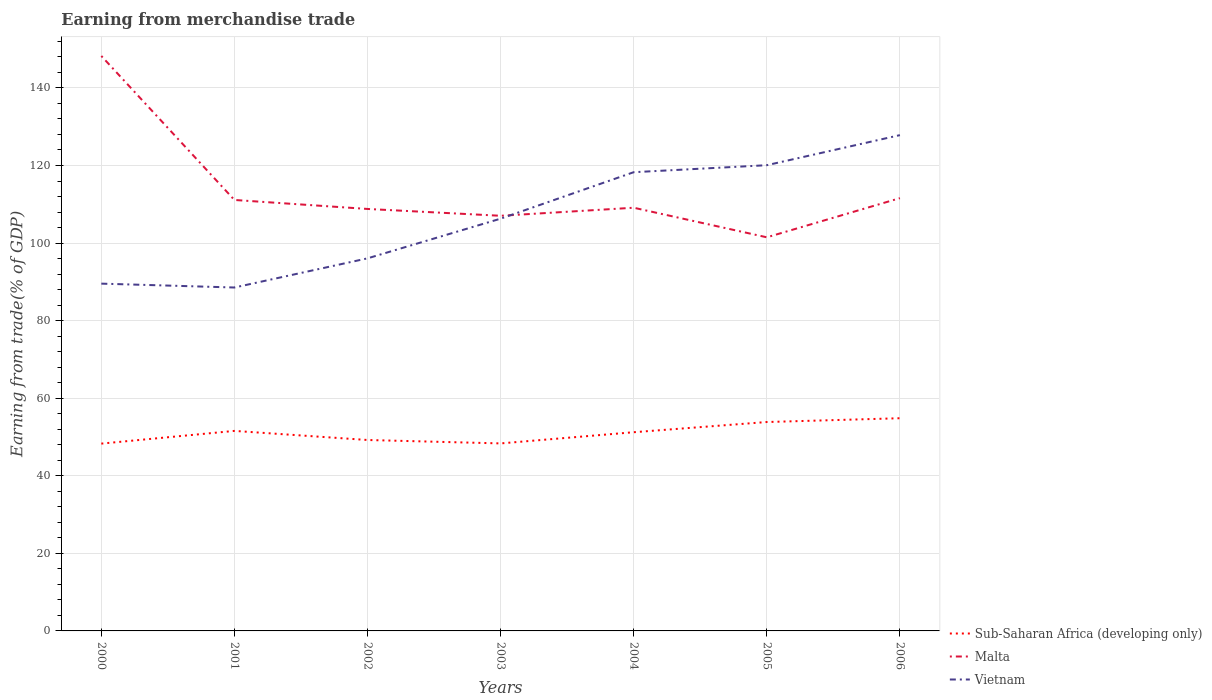How many different coloured lines are there?
Offer a terse response. 3. Is the number of lines equal to the number of legend labels?
Ensure brevity in your answer.  Yes. Across all years, what is the maximum earnings from trade in Sub-Saharan Africa (developing only)?
Provide a short and direct response. 48.29. What is the total earnings from trade in Malta in the graph?
Your answer should be very brief. 2.32. What is the difference between the highest and the second highest earnings from trade in Sub-Saharan Africa (developing only)?
Your answer should be compact. 6.54. Is the earnings from trade in Vietnam strictly greater than the earnings from trade in Sub-Saharan Africa (developing only) over the years?
Provide a succinct answer. No. How many lines are there?
Your answer should be compact. 3. How many years are there in the graph?
Provide a short and direct response. 7. What is the difference between two consecutive major ticks on the Y-axis?
Provide a succinct answer. 20. Does the graph contain any zero values?
Offer a very short reply. No. Does the graph contain grids?
Give a very brief answer. Yes. What is the title of the graph?
Give a very brief answer. Earning from merchandise trade. Does "Vanuatu" appear as one of the legend labels in the graph?
Your response must be concise. No. What is the label or title of the Y-axis?
Make the answer very short. Earning from trade(% of GDP). What is the Earning from trade(% of GDP) in Sub-Saharan Africa (developing only) in 2000?
Keep it short and to the point. 48.29. What is the Earning from trade(% of GDP) of Malta in 2000?
Your answer should be compact. 148.24. What is the Earning from trade(% of GDP) in Vietnam in 2000?
Your answer should be very brief. 89.54. What is the Earning from trade(% of GDP) in Sub-Saharan Africa (developing only) in 2001?
Offer a terse response. 51.57. What is the Earning from trade(% of GDP) of Malta in 2001?
Make the answer very short. 111.11. What is the Earning from trade(% of GDP) of Vietnam in 2001?
Give a very brief answer. 88.54. What is the Earning from trade(% of GDP) in Sub-Saharan Africa (developing only) in 2002?
Make the answer very short. 49.22. What is the Earning from trade(% of GDP) in Malta in 2002?
Your response must be concise. 108.79. What is the Earning from trade(% of GDP) in Vietnam in 2002?
Ensure brevity in your answer.  96.06. What is the Earning from trade(% of GDP) of Sub-Saharan Africa (developing only) in 2003?
Give a very brief answer. 48.35. What is the Earning from trade(% of GDP) in Malta in 2003?
Provide a succinct answer. 107.03. What is the Earning from trade(% of GDP) of Vietnam in 2003?
Offer a very short reply. 106.29. What is the Earning from trade(% of GDP) of Sub-Saharan Africa (developing only) in 2004?
Provide a short and direct response. 51.23. What is the Earning from trade(% of GDP) in Malta in 2004?
Your answer should be compact. 109.11. What is the Earning from trade(% of GDP) of Vietnam in 2004?
Keep it short and to the point. 118.27. What is the Earning from trade(% of GDP) in Sub-Saharan Africa (developing only) in 2005?
Ensure brevity in your answer.  53.86. What is the Earning from trade(% of GDP) of Malta in 2005?
Give a very brief answer. 101.48. What is the Earning from trade(% of GDP) of Vietnam in 2005?
Provide a succinct answer. 120.07. What is the Earning from trade(% of GDP) in Sub-Saharan Africa (developing only) in 2006?
Make the answer very short. 54.84. What is the Earning from trade(% of GDP) of Malta in 2006?
Provide a succinct answer. 111.58. What is the Earning from trade(% of GDP) of Vietnam in 2006?
Provide a short and direct response. 127.83. Across all years, what is the maximum Earning from trade(% of GDP) in Sub-Saharan Africa (developing only)?
Your response must be concise. 54.84. Across all years, what is the maximum Earning from trade(% of GDP) of Malta?
Give a very brief answer. 148.24. Across all years, what is the maximum Earning from trade(% of GDP) of Vietnam?
Offer a terse response. 127.83. Across all years, what is the minimum Earning from trade(% of GDP) in Sub-Saharan Africa (developing only)?
Keep it short and to the point. 48.29. Across all years, what is the minimum Earning from trade(% of GDP) of Malta?
Give a very brief answer. 101.48. Across all years, what is the minimum Earning from trade(% of GDP) in Vietnam?
Keep it short and to the point. 88.54. What is the total Earning from trade(% of GDP) in Sub-Saharan Africa (developing only) in the graph?
Your answer should be compact. 357.36. What is the total Earning from trade(% of GDP) of Malta in the graph?
Make the answer very short. 797.35. What is the total Earning from trade(% of GDP) in Vietnam in the graph?
Keep it short and to the point. 746.6. What is the difference between the Earning from trade(% of GDP) of Sub-Saharan Africa (developing only) in 2000 and that in 2001?
Make the answer very short. -3.28. What is the difference between the Earning from trade(% of GDP) in Malta in 2000 and that in 2001?
Provide a succinct answer. 37.13. What is the difference between the Earning from trade(% of GDP) of Vietnam in 2000 and that in 2001?
Your answer should be very brief. 1. What is the difference between the Earning from trade(% of GDP) in Sub-Saharan Africa (developing only) in 2000 and that in 2002?
Offer a terse response. -0.93. What is the difference between the Earning from trade(% of GDP) of Malta in 2000 and that in 2002?
Offer a terse response. 39.45. What is the difference between the Earning from trade(% of GDP) of Vietnam in 2000 and that in 2002?
Give a very brief answer. -6.52. What is the difference between the Earning from trade(% of GDP) in Sub-Saharan Africa (developing only) in 2000 and that in 2003?
Keep it short and to the point. -0.05. What is the difference between the Earning from trade(% of GDP) of Malta in 2000 and that in 2003?
Keep it short and to the point. 41.21. What is the difference between the Earning from trade(% of GDP) in Vietnam in 2000 and that in 2003?
Give a very brief answer. -16.75. What is the difference between the Earning from trade(% of GDP) in Sub-Saharan Africa (developing only) in 2000 and that in 2004?
Offer a terse response. -2.94. What is the difference between the Earning from trade(% of GDP) of Malta in 2000 and that in 2004?
Your answer should be very brief. 39.13. What is the difference between the Earning from trade(% of GDP) in Vietnam in 2000 and that in 2004?
Ensure brevity in your answer.  -28.73. What is the difference between the Earning from trade(% of GDP) in Sub-Saharan Africa (developing only) in 2000 and that in 2005?
Offer a very short reply. -5.57. What is the difference between the Earning from trade(% of GDP) in Malta in 2000 and that in 2005?
Keep it short and to the point. 46.76. What is the difference between the Earning from trade(% of GDP) of Vietnam in 2000 and that in 2005?
Give a very brief answer. -30.54. What is the difference between the Earning from trade(% of GDP) in Sub-Saharan Africa (developing only) in 2000 and that in 2006?
Make the answer very short. -6.54. What is the difference between the Earning from trade(% of GDP) of Malta in 2000 and that in 2006?
Keep it short and to the point. 36.66. What is the difference between the Earning from trade(% of GDP) in Vietnam in 2000 and that in 2006?
Ensure brevity in your answer.  -38.29. What is the difference between the Earning from trade(% of GDP) of Sub-Saharan Africa (developing only) in 2001 and that in 2002?
Provide a succinct answer. 2.35. What is the difference between the Earning from trade(% of GDP) of Malta in 2001 and that in 2002?
Your response must be concise. 2.32. What is the difference between the Earning from trade(% of GDP) in Vietnam in 2001 and that in 2002?
Ensure brevity in your answer.  -7.52. What is the difference between the Earning from trade(% of GDP) in Sub-Saharan Africa (developing only) in 2001 and that in 2003?
Offer a terse response. 3.23. What is the difference between the Earning from trade(% of GDP) in Malta in 2001 and that in 2003?
Make the answer very short. 4.08. What is the difference between the Earning from trade(% of GDP) of Vietnam in 2001 and that in 2003?
Your response must be concise. -17.75. What is the difference between the Earning from trade(% of GDP) of Sub-Saharan Africa (developing only) in 2001 and that in 2004?
Keep it short and to the point. 0.34. What is the difference between the Earning from trade(% of GDP) of Malta in 2001 and that in 2004?
Offer a very short reply. 2. What is the difference between the Earning from trade(% of GDP) of Vietnam in 2001 and that in 2004?
Make the answer very short. -29.73. What is the difference between the Earning from trade(% of GDP) in Sub-Saharan Africa (developing only) in 2001 and that in 2005?
Keep it short and to the point. -2.29. What is the difference between the Earning from trade(% of GDP) of Malta in 2001 and that in 2005?
Provide a short and direct response. 9.63. What is the difference between the Earning from trade(% of GDP) in Vietnam in 2001 and that in 2005?
Offer a very short reply. -31.53. What is the difference between the Earning from trade(% of GDP) in Sub-Saharan Africa (developing only) in 2001 and that in 2006?
Give a very brief answer. -3.27. What is the difference between the Earning from trade(% of GDP) of Malta in 2001 and that in 2006?
Keep it short and to the point. -0.47. What is the difference between the Earning from trade(% of GDP) of Vietnam in 2001 and that in 2006?
Your response must be concise. -39.29. What is the difference between the Earning from trade(% of GDP) in Sub-Saharan Africa (developing only) in 2002 and that in 2003?
Provide a short and direct response. 0.88. What is the difference between the Earning from trade(% of GDP) in Malta in 2002 and that in 2003?
Provide a short and direct response. 1.76. What is the difference between the Earning from trade(% of GDP) of Vietnam in 2002 and that in 2003?
Give a very brief answer. -10.23. What is the difference between the Earning from trade(% of GDP) of Sub-Saharan Africa (developing only) in 2002 and that in 2004?
Provide a succinct answer. -2.01. What is the difference between the Earning from trade(% of GDP) in Malta in 2002 and that in 2004?
Provide a succinct answer. -0.32. What is the difference between the Earning from trade(% of GDP) in Vietnam in 2002 and that in 2004?
Keep it short and to the point. -22.21. What is the difference between the Earning from trade(% of GDP) of Sub-Saharan Africa (developing only) in 2002 and that in 2005?
Offer a terse response. -4.64. What is the difference between the Earning from trade(% of GDP) in Malta in 2002 and that in 2005?
Your response must be concise. 7.31. What is the difference between the Earning from trade(% of GDP) in Vietnam in 2002 and that in 2005?
Offer a terse response. -24.02. What is the difference between the Earning from trade(% of GDP) in Sub-Saharan Africa (developing only) in 2002 and that in 2006?
Give a very brief answer. -5.61. What is the difference between the Earning from trade(% of GDP) in Malta in 2002 and that in 2006?
Offer a very short reply. -2.79. What is the difference between the Earning from trade(% of GDP) of Vietnam in 2002 and that in 2006?
Your answer should be very brief. -31.77. What is the difference between the Earning from trade(% of GDP) in Sub-Saharan Africa (developing only) in 2003 and that in 2004?
Your answer should be compact. -2.89. What is the difference between the Earning from trade(% of GDP) in Malta in 2003 and that in 2004?
Provide a succinct answer. -2.08. What is the difference between the Earning from trade(% of GDP) of Vietnam in 2003 and that in 2004?
Offer a very short reply. -11.98. What is the difference between the Earning from trade(% of GDP) of Sub-Saharan Africa (developing only) in 2003 and that in 2005?
Offer a very short reply. -5.51. What is the difference between the Earning from trade(% of GDP) in Malta in 2003 and that in 2005?
Give a very brief answer. 5.55. What is the difference between the Earning from trade(% of GDP) in Vietnam in 2003 and that in 2005?
Make the answer very short. -13.78. What is the difference between the Earning from trade(% of GDP) of Sub-Saharan Africa (developing only) in 2003 and that in 2006?
Ensure brevity in your answer.  -6.49. What is the difference between the Earning from trade(% of GDP) in Malta in 2003 and that in 2006?
Your answer should be compact. -4.55. What is the difference between the Earning from trade(% of GDP) in Vietnam in 2003 and that in 2006?
Give a very brief answer. -21.53. What is the difference between the Earning from trade(% of GDP) of Sub-Saharan Africa (developing only) in 2004 and that in 2005?
Ensure brevity in your answer.  -2.63. What is the difference between the Earning from trade(% of GDP) in Malta in 2004 and that in 2005?
Provide a short and direct response. 7.62. What is the difference between the Earning from trade(% of GDP) in Vietnam in 2004 and that in 2005?
Offer a very short reply. -1.8. What is the difference between the Earning from trade(% of GDP) of Sub-Saharan Africa (developing only) in 2004 and that in 2006?
Your answer should be very brief. -3.61. What is the difference between the Earning from trade(% of GDP) of Malta in 2004 and that in 2006?
Your answer should be very brief. -2.47. What is the difference between the Earning from trade(% of GDP) in Vietnam in 2004 and that in 2006?
Ensure brevity in your answer.  -9.56. What is the difference between the Earning from trade(% of GDP) in Sub-Saharan Africa (developing only) in 2005 and that in 2006?
Provide a succinct answer. -0.98. What is the difference between the Earning from trade(% of GDP) of Malta in 2005 and that in 2006?
Your answer should be compact. -10.09. What is the difference between the Earning from trade(% of GDP) of Vietnam in 2005 and that in 2006?
Keep it short and to the point. -7.75. What is the difference between the Earning from trade(% of GDP) of Sub-Saharan Africa (developing only) in 2000 and the Earning from trade(% of GDP) of Malta in 2001?
Your answer should be very brief. -62.82. What is the difference between the Earning from trade(% of GDP) of Sub-Saharan Africa (developing only) in 2000 and the Earning from trade(% of GDP) of Vietnam in 2001?
Ensure brevity in your answer.  -40.25. What is the difference between the Earning from trade(% of GDP) of Malta in 2000 and the Earning from trade(% of GDP) of Vietnam in 2001?
Your response must be concise. 59.7. What is the difference between the Earning from trade(% of GDP) in Sub-Saharan Africa (developing only) in 2000 and the Earning from trade(% of GDP) in Malta in 2002?
Your answer should be very brief. -60.5. What is the difference between the Earning from trade(% of GDP) of Sub-Saharan Africa (developing only) in 2000 and the Earning from trade(% of GDP) of Vietnam in 2002?
Give a very brief answer. -47.76. What is the difference between the Earning from trade(% of GDP) of Malta in 2000 and the Earning from trade(% of GDP) of Vietnam in 2002?
Your response must be concise. 52.18. What is the difference between the Earning from trade(% of GDP) in Sub-Saharan Africa (developing only) in 2000 and the Earning from trade(% of GDP) in Malta in 2003?
Your response must be concise. -58.74. What is the difference between the Earning from trade(% of GDP) in Sub-Saharan Africa (developing only) in 2000 and the Earning from trade(% of GDP) in Vietnam in 2003?
Offer a very short reply. -58. What is the difference between the Earning from trade(% of GDP) of Malta in 2000 and the Earning from trade(% of GDP) of Vietnam in 2003?
Your response must be concise. 41.95. What is the difference between the Earning from trade(% of GDP) of Sub-Saharan Africa (developing only) in 2000 and the Earning from trade(% of GDP) of Malta in 2004?
Make the answer very short. -60.82. What is the difference between the Earning from trade(% of GDP) of Sub-Saharan Africa (developing only) in 2000 and the Earning from trade(% of GDP) of Vietnam in 2004?
Ensure brevity in your answer.  -69.98. What is the difference between the Earning from trade(% of GDP) in Malta in 2000 and the Earning from trade(% of GDP) in Vietnam in 2004?
Provide a succinct answer. 29.97. What is the difference between the Earning from trade(% of GDP) in Sub-Saharan Africa (developing only) in 2000 and the Earning from trade(% of GDP) in Malta in 2005?
Your answer should be compact. -53.19. What is the difference between the Earning from trade(% of GDP) of Sub-Saharan Africa (developing only) in 2000 and the Earning from trade(% of GDP) of Vietnam in 2005?
Your answer should be compact. -71.78. What is the difference between the Earning from trade(% of GDP) of Malta in 2000 and the Earning from trade(% of GDP) of Vietnam in 2005?
Make the answer very short. 28.16. What is the difference between the Earning from trade(% of GDP) of Sub-Saharan Africa (developing only) in 2000 and the Earning from trade(% of GDP) of Malta in 2006?
Provide a short and direct response. -63.29. What is the difference between the Earning from trade(% of GDP) of Sub-Saharan Africa (developing only) in 2000 and the Earning from trade(% of GDP) of Vietnam in 2006?
Offer a terse response. -79.53. What is the difference between the Earning from trade(% of GDP) of Malta in 2000 and the Earning from trade(% of GDP) of Vietnam in 2006?
Ensure brevity in your answer.  20.41. What is the difference between the Earning from trade(% of GDP) in Sub-Saharan Africa (developing only) in 2001 and the Earning from trade(% of GDP) in Malta in 2002?
Provide a succinct answer. -57.22. What is the difference between the Earning from trade(% of GDP) of Sub-Saharan Africa (developing only) in 2001 and the Earning from trade(% of GDP) of Vietnam in 2002?
Keep it short and to the point. -44.49. What is the difference between the Earning from trade(% of GDP) of Malta in 2001 and the Earning from trade(% of GDP) of Vietnam in 2002?
Ensure brevity in your answer.  15.05. What is the difference between the Earning from trade(% of GDP) of Sub-Saharan Africa (developing only) in 2001 and the Earning from trade(% of GDP) of Malta in 2003?
Provide a succinct answer. -55.46. What is the difference between the Earning from trade(% of GDP) in Sub-Saharan Africa (developing only) in 2001 and the Earning from trade(% of GDP) in Vietnam in 2003?
Provide a short and direct response. -54.72. What is the difference between the Earning from trade(% of GDP) of Malta in 2001 and the Earning from trade(% of GDP) of Vietnam in 2003?
Give a very brief answer. 4.82. What is the difference between the Earning from trade(% of GDP) of Sub-Saharan Africa (developing only) in 2001 and the Earning from trade(% of GDP) of Malta in 2004?
Offer a very short reply. -57.54. What is the difference between the Earning from trade(% of GDP) in Sub-Saharan Africa (developing only) in 2001 and the Earning from trade(% of GDP) in Vietnam in 2004?
Provide a short and direct response. -66.7. What is the difference between the Earning from trade(% of GDP) of Malta in 2001 and the Earning from trade(% of GDP) of Vietnam in 2004?
Ensure brevity in your answer.  -7.16. What is the difference between the Earning from trade(% of GDP) in Sub-Saharan Africa (developing only) in 2001 and the Earning from trade(% of GDP) in Malta in 2005?
Your answer should be very brief. -49.91. What is the difference between the Earning from trade(% of GDP) of Sub-Saharan Africa (developing only) in 2001 and the Earning from trade(% of GDP) of Vietnam in 2005?
Provide a short and direct response. -68.5. What is the difference between the Earning from trade(% of GDP) in Malta in 2001 and the Earning from trade(% of GDP) in Vietnam in 2005?
Ensure brevity in your answer.  -8.96. What is the difference between the Earning from trade(% of GDP) in Sub-Saharan Africa (developing only) in 2001 and the Earning from trade(% of GDP) in Malta in 2006?
Offer a very short reply. -60.01. What is the difference between the Earning from trade(% of GDP) of Sub-Saharan Africa (developing only) in 2001 and the Earning from trade(% of GDP) of Vietnam in 2006?
Your answer should be very brief. -76.26. What is the difference between the Earning from trade(% of GDP) in Malta in 2001 and the Earning from trade(% of GDP) in Vietnam in 2006?
Provide a succinct answer. -16.72. What is the difference between the Earning from trade(% of GDP) in Sub-Saharan Africa (developing only) in 2002 and the Earning from trade(% of GDP) in Malta in 2003?
Your response must be concise. -57.81. What is the difference between the Earning from trade(% of GDP) of Sub-Saharan Africa (developing only) in 2002 and the Earning from trade(% of GDP) of Vietnam in 2003?
Offer a terse response. -57.07. What is the difference between the Earning from trade(% of GDP) in Malta in 2002 and the Earning from trade(% of GDP) in Vietnam in 2003?
Provide a succinct answer. 2.5. What is the difference between the Earning from trade(% of GDP) of Sub-Saharan Africa (developing only) in 2002 and the Earning from trade(% of GDP) of Malta in 2004?
Make the answer very short. -59.88. What is the difference between the Earning from trade(% of GDP) of Sub-Saharan Africa (developing only) in 2002 and the Earning from trade(% of GDP) of Vietnam in 2004?
Provide a short and direct response. -69.04. What is the difference between the Earning from trade(% of GDP) in Malta in 2002 and the Earning from trade(% of GDP) in Vietnam in 2004?
Provide a succinct answer. -9.48. What is the difference between the Earning from trade(% of GDP) in Sub-Saharan Africa (developing only) in 2002 and the Earning from trade(% of GDP) in Malta in 2005?
Provide a succinct answer. -52.26. What is the difference between the Earning from trade(% of GDP) in Sub-Saharan Africa (developing only) in 2002 and the Earning from trade(% of GDP) in Vietnam in 2005?
Make the answer very short. -70.85. What is the difference between the Earning from trade(% of GDP) of Malta in 2002 and the Earning from trade(% of GDP) of Vietnam in 2005?
Make the answer very short. -11.28. What is the difference between the Earning from trade(% of GDP) in Sub-Saharan Africa (developing only) in 2002 and the Earning from trade(% of GDP) in Malta in 2006?
Provide a succinct answer. -62.35. What is the difference between the Earning from trade(% of GDP) of Sub-Saharan Africa (developing only) in 2002 and the Earning from trade(% of GDP) of Vietnam in 2006?
Your answer should be compact. -78.6. What is the difference between the Earning from trade(% of GDP) of Malta in 2002 and the Earning from trade(% of GDP) of Vietnam in 2006?
Provide a short and direct response. -19.03. What is the difference between the Earning from trade(% of GDP) of Sub-Saharan Africa (developing only) in 2003 and the Earning from trade(% of GDP) of Malta in 2004?
Offer a terse response. -60.76. What is the difference between the Earning from trade(% of GDP) of Sub-Saharan Africa (developing only) in 2003 and the Earning from trade(% of GDP) of Vietnam in 2004?
Ensure brevity in your answer.  -69.92. What is the difference between the Earning from trade(% of GDP) of Malta in 2003 and the Earning from trade(% of GDP) of Vietnam in 2004?
Offer a very short reply. -11.24. What is the difference between the Earning from trade(% of GDP) of Sub-Saharan Africa (developing only) in 2003 and the Earning from trade(% of GDP) of Malta in 2005?
Your answer should be very brief. -53.14. What is the difference between the Earning from trade(% of GDP) in Sub-Saharan Africa (developing only) in 2003 and the Earning from trade(% of GDP) in Vietnam in 2005?
Provide a short and direct response. -71.73. What is the difference between the Earning from trade(% of GDP) in Malta in 2003 and the Earning from trade(% of GDP) in Vietnam in 2005?
Provide a short and direct response. -13.04. What is the difference between the Earning from trade(% of GDP) in Sub-Saharan Africa (developing only) in 2003 and the Earning from trade(% of GDP) in Malta in 2006?
Offer a terse response. -63.23. What is the difference between the Earning from trade(% of GDP) of Sub-Saharan Africa (developing only) in 2003 and the Earning from trade(% of GDP) of Vietnam in 2006?
Your answer should be compact. -79.48. What is the difference between the Earning from trade(% of GDP) of Malta in 2003 and the Earning from trade(% of GDP) of Vietnam in 2006?
Your answer should be very brief. -20.79. What is the difference between the Earning from trade(% of GDP) of Sub-Saharan Africa (developing only) in 2004 and the Earning from trade(% of GDP) of Malta in 2005?
Your response must be concise. -50.25. What is the difference between the Earning from trade(% of GDP) in Sub-Saharan Africa (developing only) in 2004 and the Earning from trade(% of GDP) in Vietnam in 2005?
Give a very brief answer. -68.84. What is the difference between the Earning from trade(% of GDP) of Malta in 2004 and the Earning from trade(% of GDP) of Vietnam in 2005?
Your response must be concise. -10.97. What is the difference between the Earning from trade(% of GDP) in Sub-Saharan Africa (developing only) in 2004 and the Earning from trade(% of GDP) in Malta in 2006?
Your answer should be compact. -60.35. What is the difference between the Earning from trade(% of GDP) of Sub-Saharan Africa (developing only) in 2004 and the Earning from trade(% of GDP) of Vietnam in 2006?
Offer a very short reply. -76.6. What is the difference between the Earning from trade(% of GDP) in Malta in 2004 and the Earning from trade(% of GDP) in Vietnam in 2006?
Offer a terse response. -18.72. What is the difference between the Earning from trade(% of GDP) in Sub-Saharan Africa (developing only) in 2005 and the Earning from trade(% of GDP) in Malta in 2006?
Offer a very short reply. -57.72. What is the difference between the Earning from trade(% of GDP) in Sub-Saharan Africa (developing only) in 2005 and the Earning from trade(% of GDP) in Vietnam in 2006?
Offer a very short reply. -73.97. What is the difference between the Earning from trade(% of GDP) of Malta in 2005 and the Earning from trade(% of GDP) of Vietnam in 2006?
Your response must be concise. -26.34. What is the average Earning from trade(% of GDP) of Sub-Saharan Africa (developing only) per year?
Your answer should be very brief. 51.05. What is the average Earning from trade(% of GDP) in Malta per year?
Your answer should be very brief. 113.91. What is the average Earning from trade(% of GDP) in Vietnam per year?
Offer a terse response. 106.66. In the year 2000, what is the difference between the Earning from trade(% of GDP) in Sub-Saharan Africa (developing only) and Earning from trade(% of GDP) in Malta?
Offer a terse response. -99.95. In the year 2000, what is the difference between the Earning from trade(% of GDP) of Sub-Saharan Africa (developing only) and Earning from trade(% of GDP) of Vietnam?
Your answer should be compact. -41.24. In the year 2000, what is the difference between the Earning from trade(% of GDP) of Malta and Earning from trade(% of GDP) of Vietnam?
Offer a terse response. 58.7. In the year 2001, what is the difference between the Earning from trade(% of GDP) in Sub-Saharan Africa (developing only) and Earning from trade(% of GDP) in Malta?
Keep it short and to the point. -59.54. In the year 2001, what is the difference between the Earning from trade(% of GDP) of Sub-Saharan Africa (developing only) and Earning from trade(% of GDP) of Vietnam?
Make the answer very short. -36.97. In the year 2001, what is the difference between the Earning from trade(% of GDP) in Malta and Earning from trade(% of GDP) in Vietnam?
Keep it short and to the point. 22.57. In the year 2002, what is the difference between the Earning from trade(% of GDP) of Sub-Saharan Africa (developing only) and Earning from trade(% of GDP) of Malta?
Your response must be concise. -59.57. In the year 2002, what is the difference between the Earning from trade(% of GDP) in Sub-Saharan Africa (developing only) and Earning from trade(% of GDP) in Vietnam?
Offer a terse response. -46.83. In the year 2002, what is the difference between the Earning from trade(% of GDP) of Malta and Earning from trade(% of GDP) of Vietnam?
Offer a very short reply. 12.74. In the year 2003, what is the difference between the Earning from trade(% of GDP) of Sub-Saharan Africa (developing only) and Earning from trade(% of GDP) of Malta?
Give a very brief answer. -58.69. In the year 2003, what is the difference between the Earning from trade(% of GDP) of Sub-Saharan Africa (developing only) and Earning from trade(% of GDP) of Vietnam?
Ensure brevity in your answer.  -57.95. In the year 2003, what is the difference between the Earning from trade(% of GDP) in Malta and Earning from trade(% of GDP) in Vietnam?
Make the answer very short. 0.74. In the year 2004, what is the difference between the Earning from trade(% of GDP) in Sub-Saharan Africa (developing only) and Earning from trade(% of GDP) in Malta?
Provide a short and direct response. -57.88. In the year 2004, what is the difference between the Earning from trade(% of GDP) of Sub-Saharan Africa (developing only) and Earning from trade(% of GDP) of Vietnam?
Keep it short and to the point. -67.04. In the year 2004, what is the difference between the Earning from trade(% of GDP) in Malta and Earning from trade(% of GDP) in Vietnam?
Provide a succinct answer. -9.16. In the year 2005, what is the difference between the Earning from trade(% of GDP) of Sub-Saharan Africa (developing only) and Earning from trade(% of GDP) of Malta?
Offer a very short reply. -47.62. In the year 2005, what is the difference between the Earning from trade(% of GDP) of Sub-Saharan Africa (developing only) and Earning from trade(% of GDP) of Vietnam?
Provide a succinct answer. -66.21. In the year 2005, what is the difference between the Earning from trade(% of GDP) in Malta and Earning from trade(% of GDP) in Vietnam?
Your answer should be very brief. -18.59. In the year 2006, what is the difference between the Earning from trade(% of GDP) in Sub-Saharan Africa (developing only) and Earning from trade(% of GDP) in Malta?
Your response must be concise. -56.74. In the year 2006, what is the difference between the Earning from trade(% of GDP) in Sub-Saharan Africa (developing only) and Earning from trade(% of GDP) in Vietnam?
Your response must be concise. -72.99. In the year 2006, what is the difference between the Earning from trade(% of GDP) in Malta and Earning from trade(% of GDP) in Vietnam?
Keep it short and to the point. -16.25. What is the ratio of the Earning from trade(% of GDP) in Sub-Saharan Africa (developing only) in 2000 to that in 2001?
Give a very brief answer. 0.94. What is the ratio of the Earning from trade(% of GDP) of Malta in 2000 to that in 2001?
Provide a short and direct response. 1.33. What is the ratio of the Earning from trade(% of GDP) in Vietnam in 2000 to that in 2001?
Your answer should be compact. 1.01. What is the ratio of the Earning from trade(% of GDP) in Sub-Saharan Africa (developing only) in 2000 to that in 2002?
Offer a terse response. 0.98. What is the ratio of the Earning from trade(% of GDP) in Malta in 2000 to that in 2002?
Make the answer very short. 1.36. What is the ratio of the Earning from trade(% of GDP) of Vietnam in 2000 to that in 2002?
Your answer should be compact. 0.93. What is the ratio of the Earning from trade(% of GDP) of Sub-Saharan Africa (developing only) in 2000 to that in 2003?
Keep it short and to the point. 1. What is the ratio of the Earning from trade(% of GDP) in Malta in 2000 to that in 2003?
Provide a short and direct response. 1.39. What is the ratio of the Earning from trade(% of GDP) of Vietnam in 2000 to that in 2003?
Make the answer very short. 0.84. What is the ratio of the Earning from trade(% of GDP) in Sub-Saharan Africa (developing only) in 2000 to that in 2004?
Offer a very short reply. 0.94. What is the ratio of the Earning from trade(% of GDP) of Malta in 2000 to that in 2004?
Keep it short and to the point. 1.36. What is the ratio of the Earning from trade(% of GDP) of Vietnam in 2000 to that in 2004?
Offer a very short reply. 0.76. What is the ratio of the Earning from trade(% of GDP) of Sub-Saharan Africa (developing only) in 2000 to that in 2005?
Ensure brevity in your answer.  0.9. What is the ratio of the Earning from trade(% of GDP) in Malta in 2000 to that in 2005?
Your answer should be very brief. 1.46. What is the ratio of the Earning from trade(% of GDP) in Vietnam in 2000 to that in 2005?
Provide a short and direct response. 0.75. What is the ratio of the Earning from trade(% of GDP) of Sub-Saharan Africa (developing only) in 2000 to that in 2006?
Keep it short and to the point. 0.88. What is the ratio of the Earning from trade(% of GDP) of Malta in 2000 to that in 2006?
Your answer should be very brief. 1.33. What is the ratio of the Earning from trade(% of GDP) in Vietnam in 2000 to that in 2006?
Offer a very short reply. 0.7. What is the ratio of the Earning from trade(% of GDP) in Sub-Saharan Africa (developing only) in 2001 to that in 2002?
Give a very brief answer. 1.05. What is the ratio of the Earning from trade(% of GDP) of Malta in 2001 to that in 2002?
Offer a very short reply. 1.02. What is the ratio of the Earning from trade(% of GDP) in Vietnam in 2001 to that in 2002?
Your answer should be very brief. 0.92. What is the ratio of the Earning from trade(% of GDP) in Sub-Saharan Africa (developing only) in 2001 to that in 2003?
Ensure brevity in your answer.  1.07. What is the ratio of the Earning from trade(% of GDP) of Malta in 2001 to that in 2003?
Provide a short and direct response. 1.04. What is the ratio of the Earning from trade(% of GDP) in Vietnam in 2001 to that in 2003?
Provide a succinct answer. 0.83. What is the ratio of the Earning from trade(% of GDP) in Sub-Saharan Africa (developing only) in 2001 to that in 2004?
Ensure brevity in your answer.  1.01. What is the ratio of the Earning from trade(% of GDP) of Malta in 2001 to that in 2004?
Make the answer very short. 1.02. What is the ratio of the Earning from trade(% of GDP) of Vietnam in 2001 to that in 2004?
Make the answer very short. 0.75. What is the ratio of the Earning from trade(% of GDP) of Sub-Saharan Africa (developing only) in 2001 to that in 2005?
Your answer should be compact. 0.96. What is the ratio of the Earning from trade(% of GDP) of Malta in 2001 to that in 2005?
Your answer should be very brief. 1.09. What is the ratio of the Earning from trade(% of GDP) in Vietnam in 2001 to that in 2005?
Ensure brevity in your answer.  0.74. What is the ratio of the Earning from trade(% of GDP) of Sub-Saharan Africa (developing only) in 2001 to that in 2006?
Ensure brevity in your answer.  0.94. What is the ratio of the Earning from trade(% of GDP) of Vietnam in 2001 to that in 2006?
Provide a succinct answer. 0.69. What is the ratio of the Earning from trade(% of GDP) of Sub-Saharan Africa (developing only) in 2002 to that in 2003?
Your answer should be compact. 1.02. What is the ratio of the Earning from trade(% of GDP) of Malta in 2002 to that in 2003?
Your response must be concise. 1.02. What is the ratio of the Earning from trade(% of GDP) in Vietnam in 2002 to that in 2003?
Your response must be concise. 0.9. What is the ratio of the Earning from trade(% of GDP) in Sub-Saharan Africa (developing only) in 2002 to that in 2004?
Keep it short and to the point. 0.96. What is the ratio of the Earning from trade(% of GDP) in Malta in 2002 to that in 2004?
Keep it short and to the point. 1. What is the ratio of the Earning from trade(% of GDP) of Vietnam in 2002 to that in 2004?
Keep it short and to the point. 0.81. What is the ratio of the Earning from trade(% of GDP) of Sub-Saharan Africa (developing only) in 2002 to that in 2005?
Offer a terse response. 0.91. What is the ratio of the Earning from trade(% of GDP) of Malta in 2002 to that in 2005?
Give a very brief answer. 1.07. What is the ratio of the Earning from trade(% of GDP) in Vietnam in 2002 to that in 2005?
Ensure brevity in your answer.  0.8. What is the ratio of the Earning from trade(% of GDP) of Sub-Saharan Africa (developing only) in 2002 to that in 2006?
Keep it short and to the point. 0.9. What is the ratio of the Earning from trade(% of GDP) in Malta in 2002 to that in 2006?
Make the answer very short. 0.97. What is the ratio of the Earning from trade(% of GDP) of Vietnam in 2002 to that in 2006?
Make the answer very short. 0.75. What is the ratio of the Earning from trade(% of GDP) of Sub-Saharan Africa (developing only) in 2003 to that in 2004?
Offer a very short reply. 0.94. What is the ratio of the Earning from trade(% of GDP) of Vietnam in 2003 to that in 2004?
Provide a short and direct response. 0.9. What is the ratio of the Earning from trade(% of GDP) in Sub-Saharan Africa (developing only) in 2003 to that in 2005?
Make the answer very short. 0.9. What is the ratio of the Earning from trade(% of GDP) in Malta in 2003 to that in 2005?
Provide a short and direct response. 1.05. What is the ratio of the Earning from trade(% of GDP) in Vietnam in 2003 to that in 2005?
Make the answer very short. 0.89. What is the ratio of the Earning from trade(% of GDP) in Sub-Saharan Africa (developing only) in 2003 to that in 2006?
Your response must be concise. 0.88. What is the ratio of the Earning from trade(% of GDP) of Malta in 2003 to that in 2006?
Offer a terse response. 0.96. What is the ratio of the Earning from trade(% of GDP) of Vietnam in 2003 to that in 2006?
Offer a very short reply. 0.83. What is the ratio of the Earning from trade(% of GDP) of Sub-Saharan Africa (developing only) in 2004 to that in 2005?
Your answer should be compact. 0.95. What is the ratio of the Earning from trade(% of GDP) in Malta in 2004 to that in 2005?
Ensure brevity in your answer.  1.08. What is the ratio of the Earning from trade(% of GDP) in Sub-Saharan Africa (developing only) in 2004 to that in 2006?
Ensure brevity in your answer.  0.93. What is the ratio of the Earning from trade(% of GDP) of Malta in 2004 to that in 2006?
Provide a succinct answer. 0.98. What is the ratio of the Earning from trade(% of GDP) in Vietnam in 2004 to that in 2006?
Your response must be concise. 0.93. What is the ratio of the Earning from trade(% of GDP) in Sub-Saharan Africa (developing only) in 2005 to that in 2006?
Make the answer very short. 0.98. What is the ratio of the Earning from trade(% of GDP) of Malta in 2005 to that in 2006?
Your response must be concise. 0.91. What is the ratio of the Earning from trade(% of GDP) of Vietnam in 2005 to that in 2006?
Offer a terse response. 0.94. What is the difference between the highest and the second highest Earning from trade(% of GDP) of Sub-Saharan Africa (developing only)?
Give a very brief answer. 0.98. What is the difference between the highest and the second highest Earning from trade(% of GDP) of Malta?
Make the answer very short. 36.66. What is the difference between the highest and the second highest Earning from trade(% of GDP) of Vietnam?
Give a very brief answer. 7.75. What is the difference between the highest and the lowest Earning from trade(% of GDP) in Sub-Saharan Africa (developing only)?
Offer a very short reply. 6.54. What is the difference between the highest and the lowest Earning from trade(% of GDP) in Malta?
Offer a very short reply. 46.76. What is the difference between the highest and the lowest Earning from trade(% of GDP) in Vietnam?
Provide a short and direct response. 39.29. 